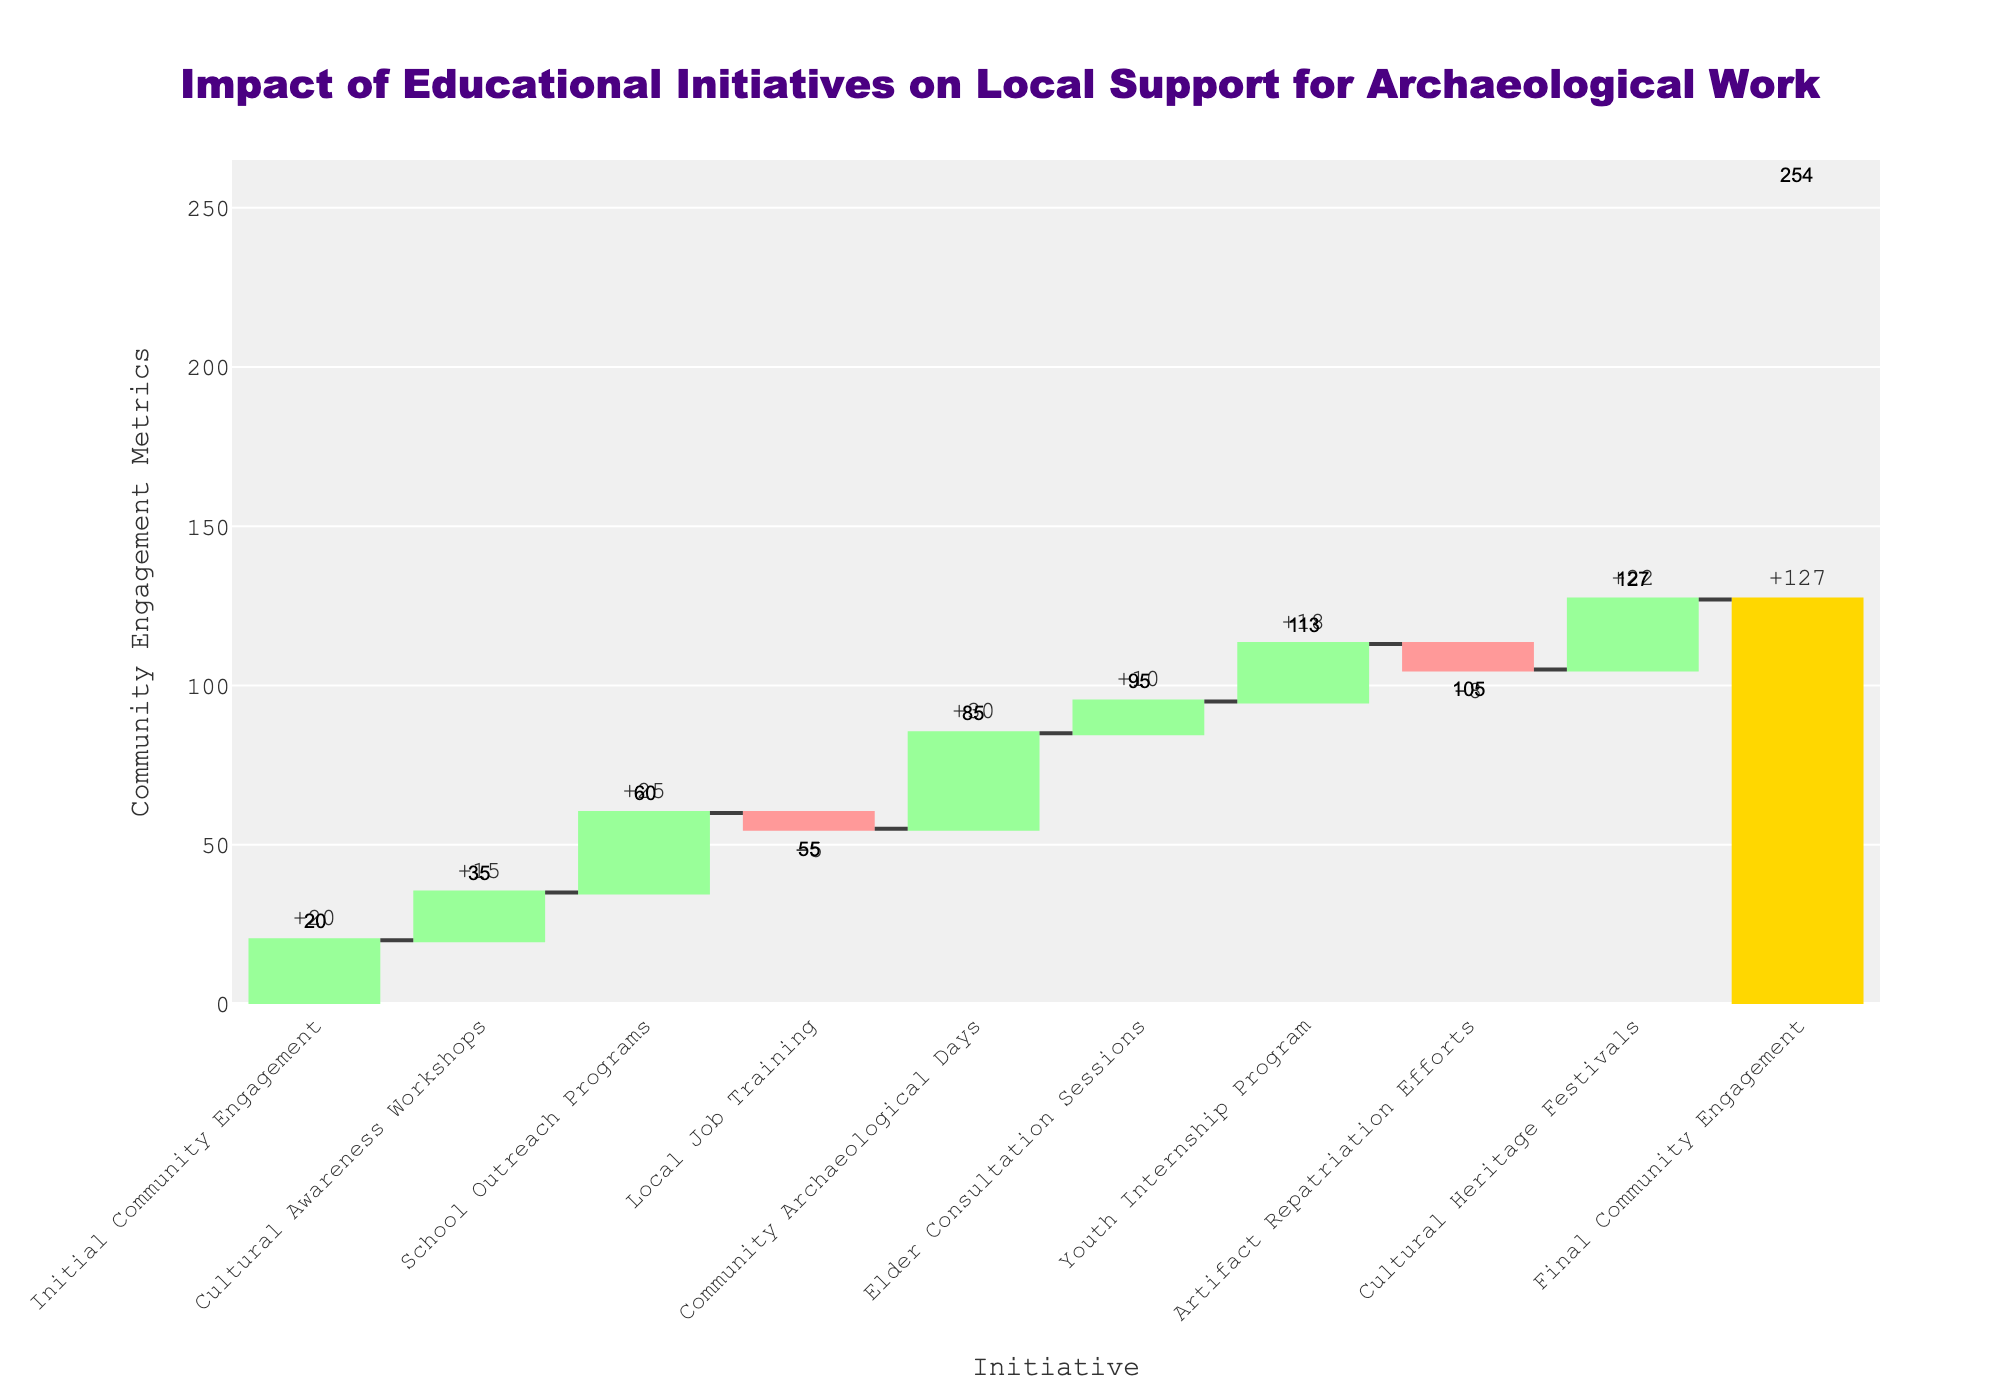What is the title of the chart? The title of the chart is displayed at the top and reads "Impact of Educational Initiatives on Local Support for Archaeological Work".
Answer: Impact of Educational Initiatives on Local Support for Archaeological Work How many categories of educational initiatives are represented in the chart? By counting the bars in the chart, you can see that there are 10 categories listed, including the final cumulative bar.
Answer: 10 What is the initial community engagement value? The initial community engagement value is shown at the beginning of the chart as 20.
Answer: 20 Which initiative had the highest positive impact on community engagement? By comparing the heights of the positive incremental bars, "Community Archaeological Days" had the highest impact with a value of 30.
Answer: Community Archaeological Days What is the final community engagement value? The final community engagement value is shown as the last bar, representing a total of 127.
Answer: 127 How much did the "Local Job Training" initiative decrease community engagement? The bar for "Local Job Training" is negative, showing a decrease of 5 community engagement points.
Answer: 5 What is the total increase in community engagement due to positive initiatives? Summing up all positive values: 15 (Cultural Awareness Workshops) + 25 (School Outreach Programs) + 30 (Community Archaeological Days) + 10 (Elder Consultation Sessions) + 18 (Youth Internship Program) + 22 (Cultural Heritage Festivals) = 120.
Answer: 120 Which initiatives had a negative impact on community engagement and by how much? The negative initiatives are "Local Job Training" with -5 and "Artifact Repatriation Efforts" with -8, summing to a total negative impact of -13.
Answer: Local Job Training (-5), Artifact Repatriation Efforts (-8) How many initiatives had a positive impact on community engagement? By counting the positive bars, there are 6 positive initiatives: Cultural Awareness Workshops, School Outreach Programs, Community Archaeological Days, Elder Consultation Sessions, Youth Internship Program, and Cultural Heritage Festivals.
Answer: 6 What is the net change in community engagement from the initial to the final value? Subtracting the initial value (20) from the final value (127) gives a net change of 107.
Answer: 107 